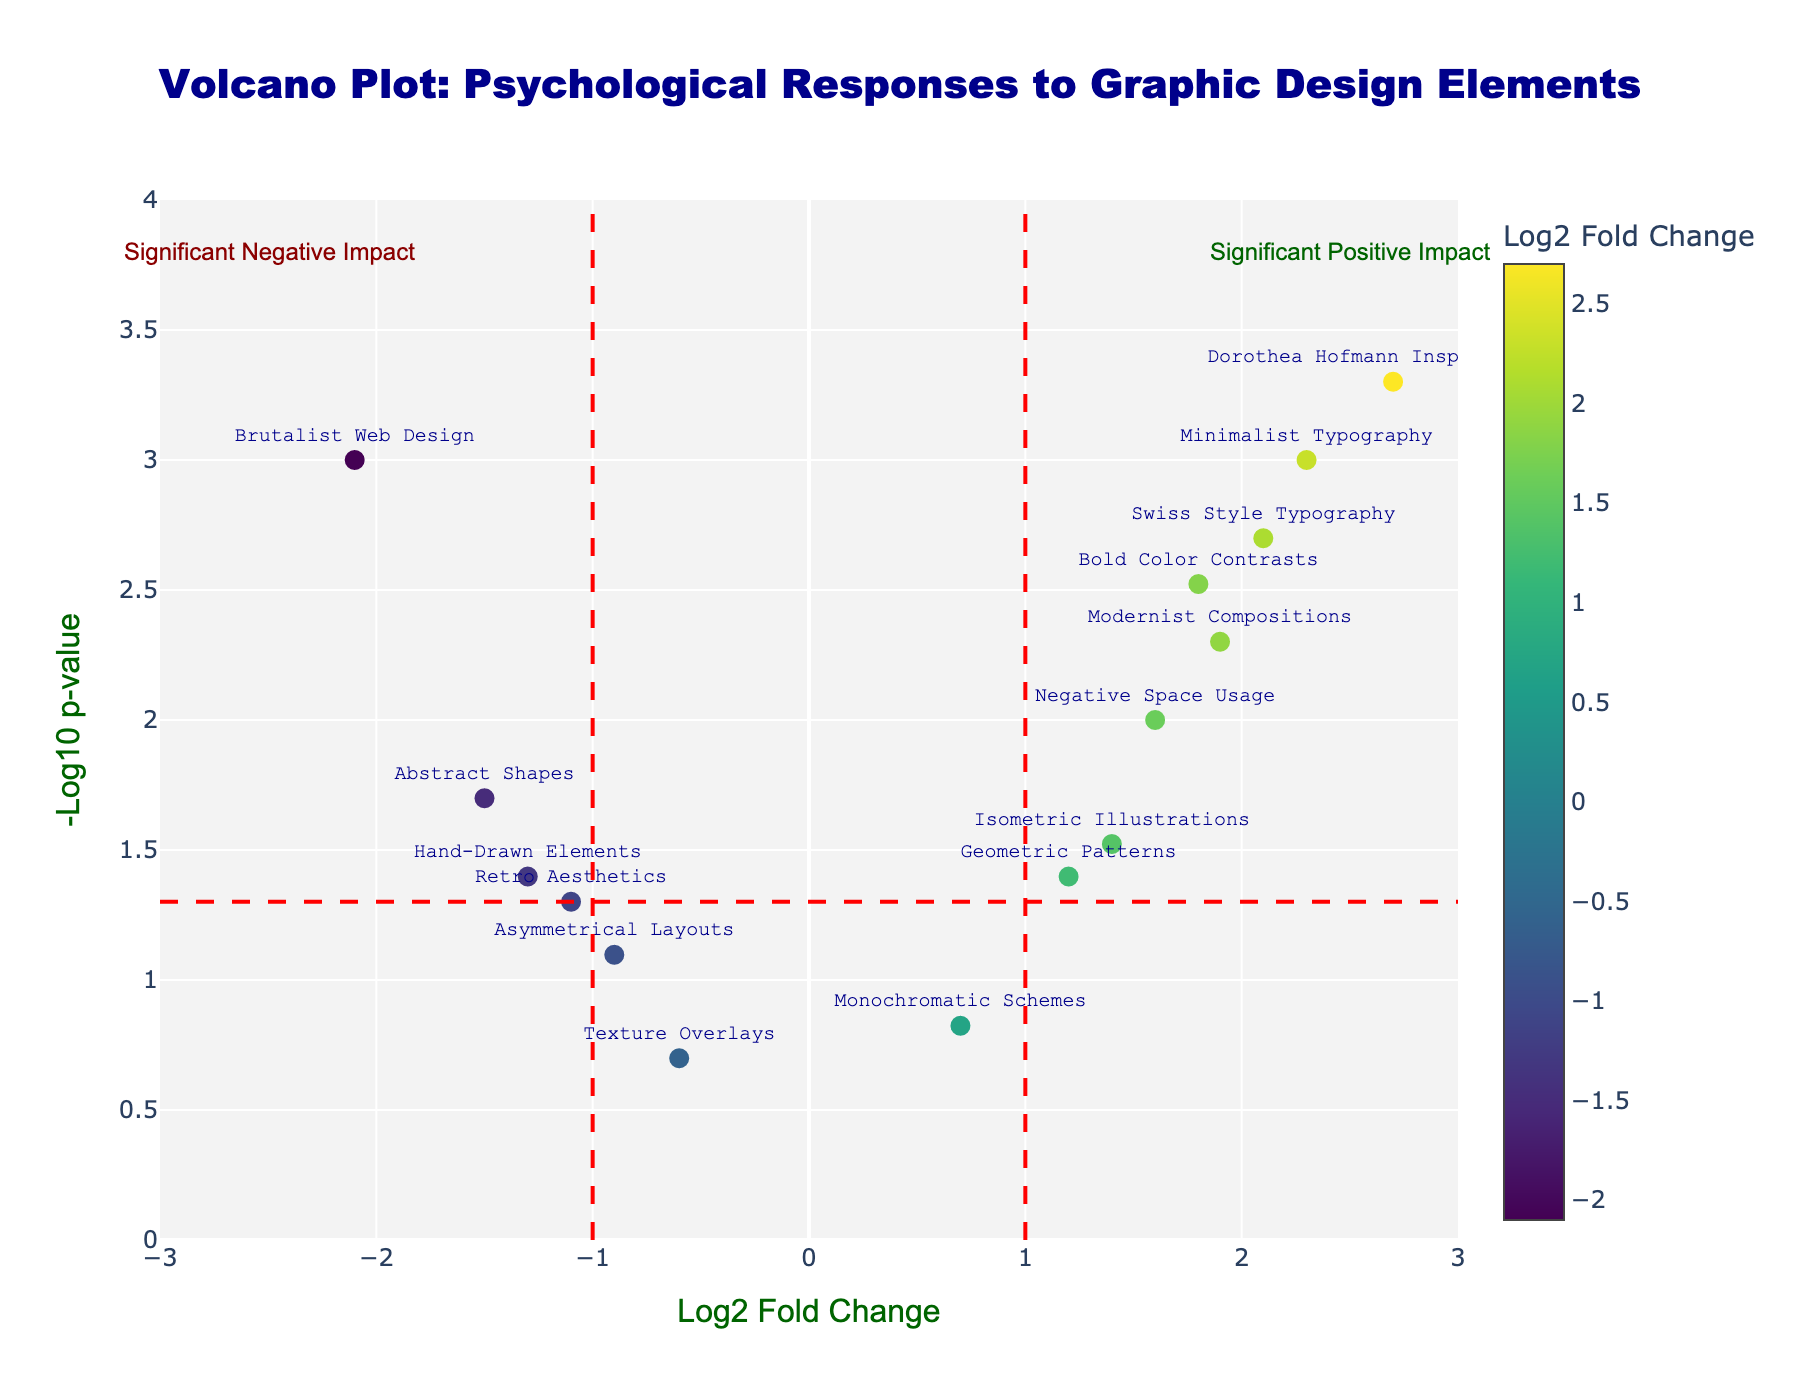What is the title of the plot? The title is located at the top of the plot, and it reads, "Volcano Plot: Psychological Responses to Graphic Design Elements".
Answer: Volcano Plot: Psychological Responses to Graphic Design Elements How many elements are plotted based on visual markers on the plot? Each data point represents an element, and by counting the markers, we can determine the number of elements, which is 15.
Answer: 15 Which graphic design element has the highest log2 fold change? By looking at the x-axis and finding the highest value, we see that "Dorothea Hofmann Inspired Grids" has the highest log2 fold change at 2.7.
Answer: Dorothea Hofmann Inspired Grids Which graphic design element has the lowest p-value? The y-axis shows the -log10(p-value). The element with the highest y-value represents the lowest p-value, which is "Dorothea Hofmann Inspired Grids" with a p-value of 0.0005.
Answer: Dorothea Hofmann Inspired Grids How many graphic design elements have a significant positive impact based on the p-value cutoff of 0.05 and log2 fold change cutoff of 1? By identifying the points with log2 fold change greater than 1 and -log10(p) greater than approximately 1.3, we find 5 elements fitting these criteria.
Answer: 5 How many elements are below the fold change cutoff of -1, indicating a significant negative impact? Look for elements with a log2 fold change less than -1 and -log10(p) greater than 1.3. Three elements meet this criterion: "Abstract Shapes," "Hand-Drawn Elements," and "Brutalist Web Design."
Answer: 3 Compare "Bold Color Contrasts" and "Modernist Compositions" regarding their p-values. Which has a higher significance? Comparing their positions on the y-axis, "Modernist Compositions" is higher with a -log10(p) around 2.3, indicating a lower p-value than "Bold Color Contrasts," which has -log10(p) of around 2.5.
Answer: Modernist Compositions Which element has a log2 fold change closest to 0 but still statistically significant? Log2 fold changes near 0 and -log10(p) greater than 1.3 (p-value < 0.05) shows "Geometric Patterns" with a log2 fold change of 1.2 and a p-value of 0.04.
Answer: Geometric Patterns What can you say about the psychological impact trend related to "Texture Overlays"? "Texture Overlays" has a log2 fold change of -0.6 and a p-value above 0.05, indicating it is neither significantly positive nor negative in psychological impact.
Answer: Not significant Which elements show strong negative reactions, and what are their log2 fold changes? Strong negative reactions are indicated by low log2 fold change (< -1) and high -log10(p) (p-value < 0.05). These elements are "Abstract Shapes" (-1.5), "Brutalist Web Design" (-2.1), and "Hand-Drawn Elements" (-1.3).
Answer: Abstract Shapes (-1.5), Brutalist Web Design (-2.1), Hand-Drawn Elements (-1.3) 